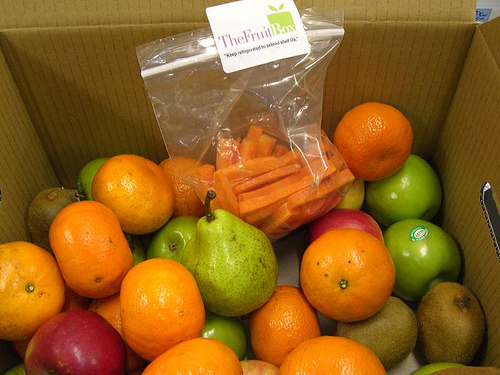Read and extract the text from this image. Box Fruit The 